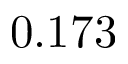<formula> <loc_0><loc_0><loc_500><loc_500>0 . 1 7 3</formula> 